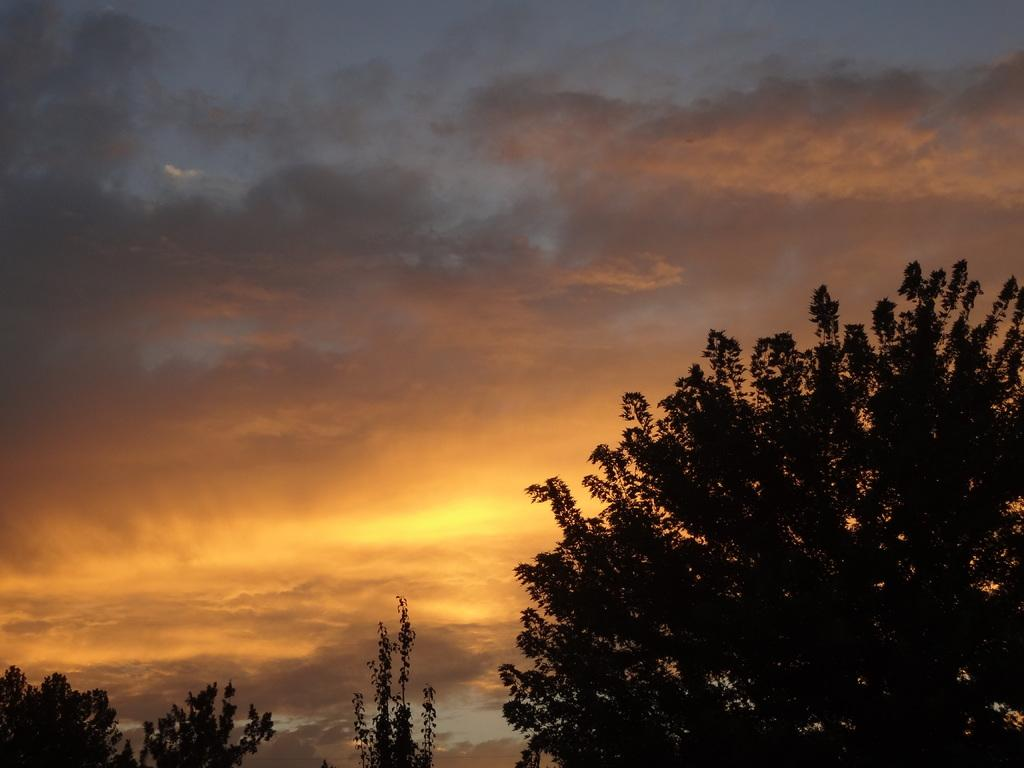What type of living organisms can be seen in the image? Plants and a tree are visible in the image. What is visible in the background of the image? The sky is visible in the image. What can be seen in the sky? There are clouds in the sky. What is the source of light in the image? Sunshine is present in the image. What type of drink is being served in the image? There is no drink present in the image; it features plants, a tree, the sky, clouds, and sunshine. What type of operation is being performed on the tree in the image? There is no operation being performed on the tree in the image; it is a natural scene with no human intervention. 